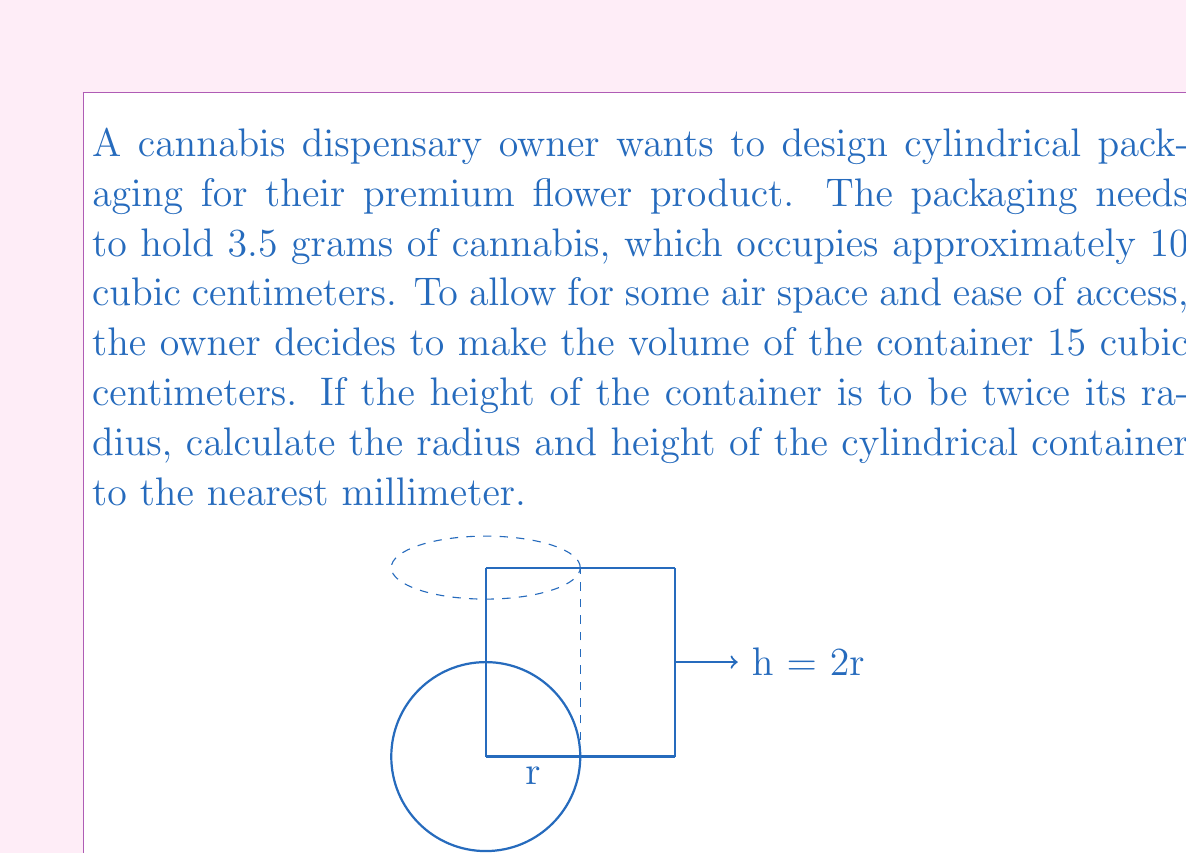Can you solve this math problem? Let's approach this step-by-step:

1) The volume of a cylinder is given by the formula:
   $$V = \pi r^2 h$$
   where $V$ is volume, $r$ is radius, and $h$ is height.

2) We're given that the height is twice the radius, so:
   $$h = 2r$$

3) Substituting this into the volume formula:
   $$V = \pi r^2 (2r) = 2\pi r^3$$

4) We know the volume needs to be 15 cubic centimeters:
   $$15 = 2\pi r^3$$

5) Solving for $r$:
   $$r^3 = \frac{15}{2\pi}$$
   $$r = \sqrt[3]{\frac{15}{2\pi}}$$

6) Using a calculator:
   $$r \approx 1.3693 \text{ cm}$$

7) Rounding to the nearest millimeter:
   $$r \approx 1.4 \text{ cm}$$

8) Since $h = 2r$:
   $$h \approx 2.8 \text{ cm}$$

Therefore, the radius should be 1.4 cm and the height should be 2.8 cm.
Answer: $r = 1.4 \text{ cm}, h = 2.8 \text{ cm}$ 